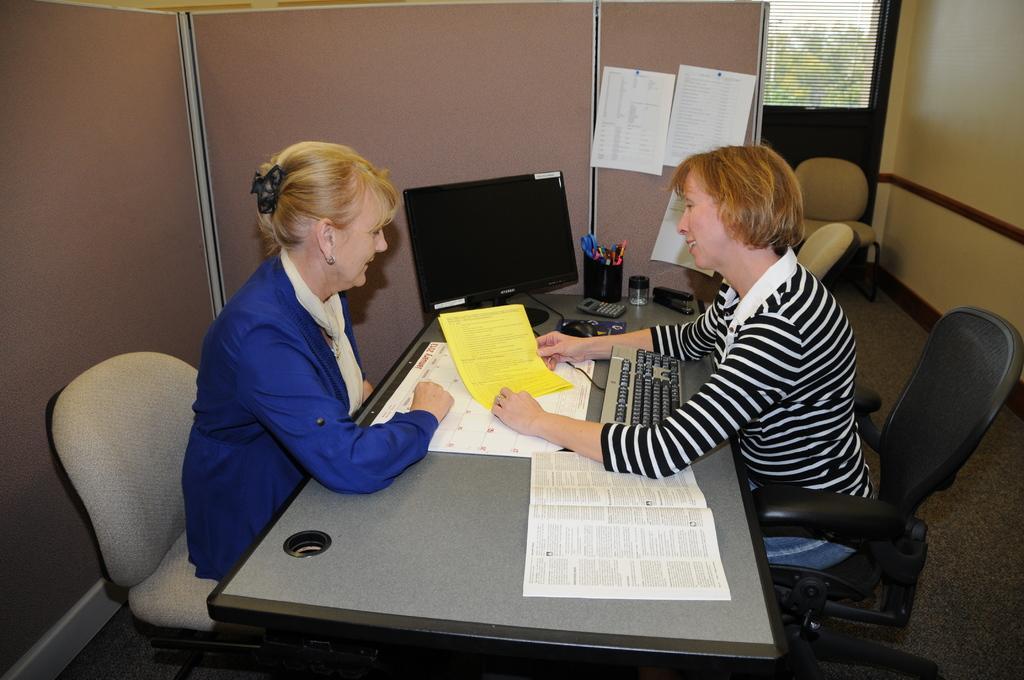Could you give a brief overview of what you see in this image? In this image, there are two women sitting on the chairs and smiling. I can see a computer monitor, calculator, mouse, keyboard, book, paper, pen stand with pens, stapler and a bottle on a table. There are pipes attached to a board. In the background, I can see a door and a chair. On the right side of the image, there is a wall. 